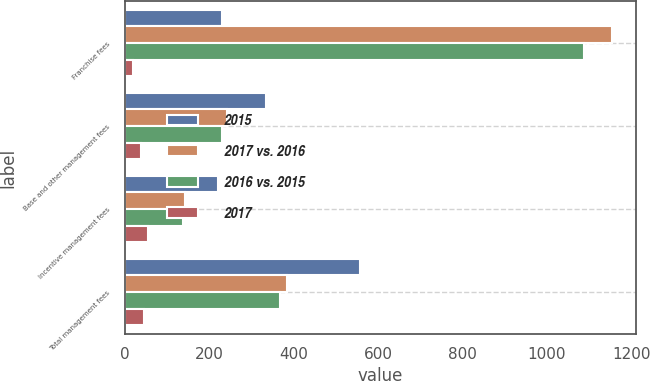<chart> <loc_0><loc_0><loc_500><loc_500><stacked_bar_chart><ecel><fcel>Franchise fees<fcel>Base and other management fees<fcel>Incentive management fees<fcel>Total management fees<nl><fcel>2015<fcel>230<fcel>336<fcel>222<fcel>558<nl><fcel>2017 vs. 2016<fcel>1154<fcel>242<fcel>142<fcel>384<nl><fcel>2016 vs. 2015<fcel>1087<fcel>230<fcel>138<fcel>368<nl><fcel>2017<fcel>19.8<fcel>38.8<fcel>56.3<fcel>45.3<nl></chart> 